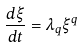Convert formula to latex. <formula><loc_0><loc_0><loc_500><loc_500>\frac { d \xi } { d t } = \lambda _ { q } \xi ^ { q }</formula> 